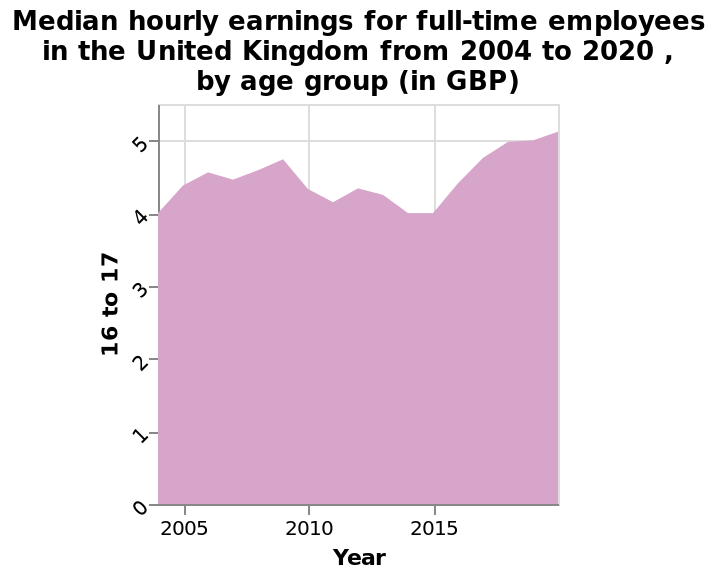<image>
How much did the earnings increase in 2020 compared to the previous year?  The earnings increased by approximately 10p in 2020. please describe the details of the chart This area graph is labeled Median hourly earnings for full-time employees in the United Kingdom from 2004 to 2020 , by age group (in GBP). The x-axis plots Year as linear scale of range 2005 to 2015 while the y-axis measures 16 to 17 with linear scale of range 0 to 5. 